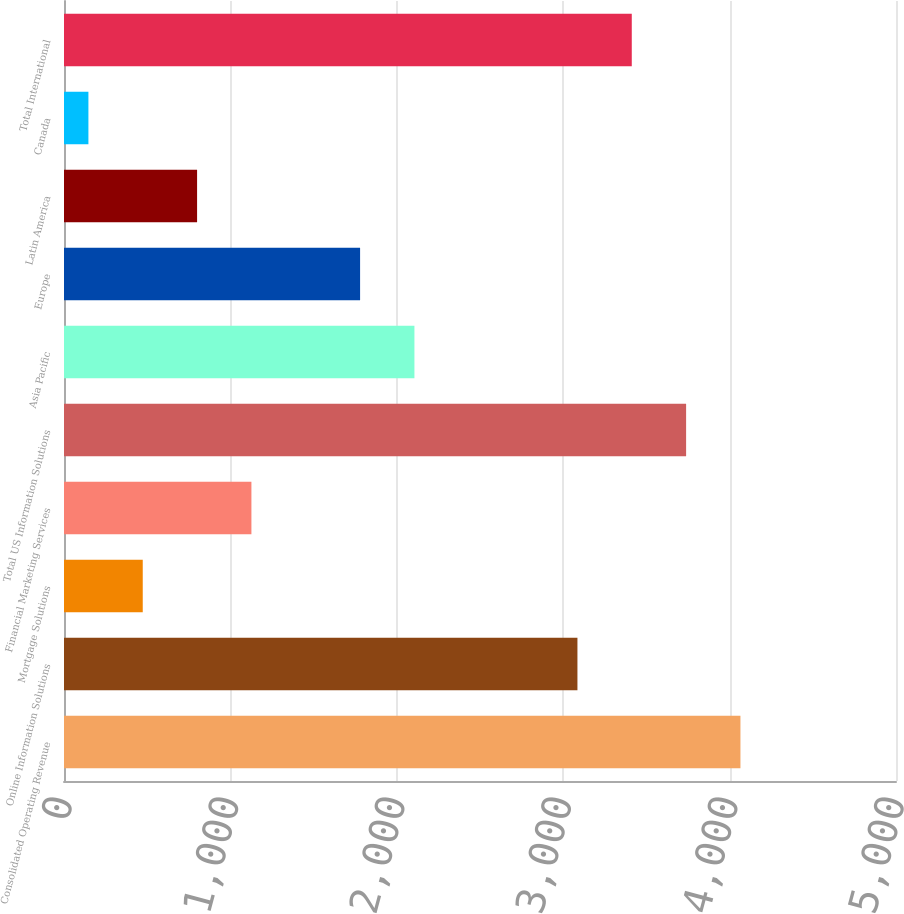Convert chart to OTSL. <chart><loc_0><loc_0><loc_500><loc_500><bar_chart><fcel>Consolidated Operating Revenue<fcel>Online Information Solutions<fcel>Mortgage Solutions<fcel>Financial Marketing Services<fcel>Total US Information Solutions<fcel>Asia Pacific<fcel>Europe<fcel>Latin America<fcel>Canada<fcel>Total International<nl><fcel>4065.18<fcel>3085.56<fcel>473.24<fcel>1126.32<fcel>3738.64<fcel>2105.94<fcel>1779.4<fcel>799.78<fcel>146.7<fcel>3412.1<nl></chart> 